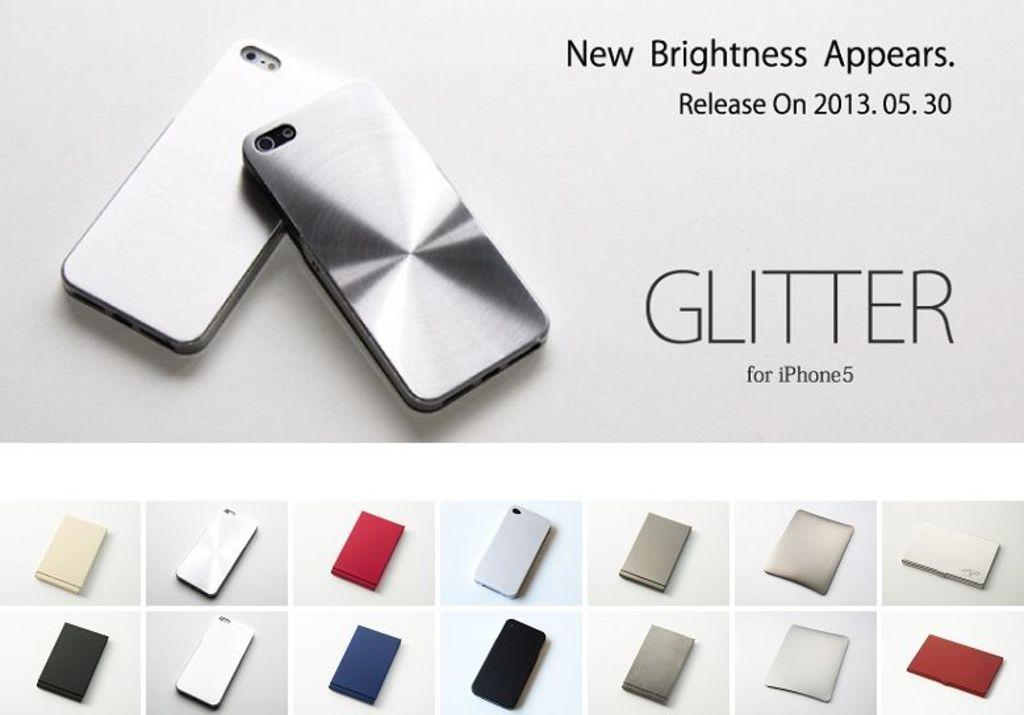What type of visual is the image? The image is a poster. What can be seen on the surface of the poster? There are mobiles on the surface of the poster. What word is present on the poster? The word "test" is present on the poster. What type of objects are depicted at the bottom of the poster? There are images of different types of devices at the bottom of the poster. What is the tendency of the fictional holiday depicted in the poster? There is no fictional holiday depicted in the poster; it features mobiles, the word "test," and images of devices. 